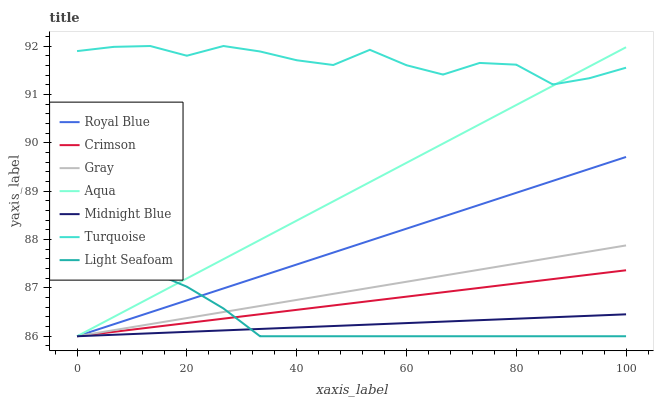Does Midnight Blue have the minimum area under the curve?
Answer yes or no. Yes. Does Turquoise have the maximum area under the curve?
Answer yes or no. Yes. Does Turquoise have the minimum area under the curve?
Answer yes or no. No. Does Midnight Blue have the maximum area under the curve?
Answer yes or no. No. Is Midnight Blue the smoothest?
Answer yes or no. Yes. Is Turquoise the roughest?
Answer yes or no. Yes. Is Turquoise the smoothest?
Answer yes or no. No. Is Midnight Blue the roughest?
Answer yes or no. No. Does Turquoise have the lowest value?
Answer yes or no. No. Does Turquoise have the highest value?
Answer yes or no. Yes. Does Midnight Blue have the highest value?
Answer yes or no. No. Is Midnight Blue less than Turquoise?
Answer yes or no. Yes. Is Turquoise greater than Light Seafoam?
Answer yes or no. Yes. Does Crimson intersect Midnight Blue?
Answer yes or no. Yes. Is Crimson less than Midnight Blue?
Answer yes or no. No. Is Crimson greater than Midnight Blue?
Answer yes or no. No. Does Midnight Blue intersect Turquoise?
Answer yes or no. No. 